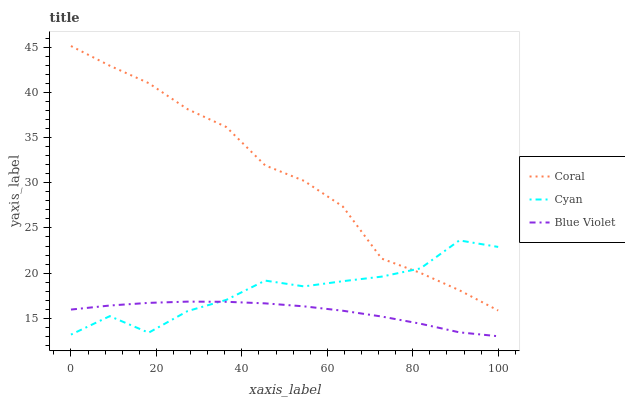Does Blue Violet have the minimum area under the curve?
Answer yes or no. Yes. Does Coral have the maximum area under the curve?
Answer yes or no. Yes. Does Coral have the minimum area under the curve?
Answer yes or no. No. Does Blue Violet have the maximum area under the curve?
Answer yes or no. No. Is Blue Violet the smoothest?
Answer yes or no. Yes. Is Cyan the roughest?
Answer yes or no. Yes. Is Coral the smoothest?
Answer yes or no. No. Is Coral the roughest?
Answer yes or no. No. Does Blue Violet have the lowest value?
Answer yes or no. Yes. Does Coral have the lowest value?
Answer yes or no. No. Does Coral have the highest value?
Answer yes or no. Yes. Does Blue Violet have the highest value?
Answer yes or no. No. Is Blue Violet less than Coral?
Answer yes or no. Yes. Is Coral greater than Blue Violet?
Answer yes or no. Yes. Does Blue Violet intersect Cyan?
Answer yes or no. Yes. Is Blue Violet less than Cyan?
Answer yes or no. No. Is Blue Violet greater than Cyan?
Answer yes or no. No. Does Blue Violet intersect Coral?
Answer yes or no. No. 